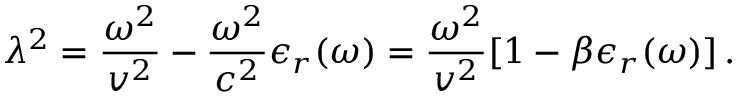<formula> <loc_0><loc_0><loc_500><loc_500>\lambda ^ { 2 } = \frac { \omega ^ { 2 } } { v ^ { 2 } } - \frac { \omega ^ { 2 } } { c ^ { 2 } } \epsilon _ { r } ( \omega ) = \frac { \omega ^ { 2 } } { v ^ { 2 } } [ 1 - \beta \epsilon _ { r } ( \omega ) ] \, .</formula> 